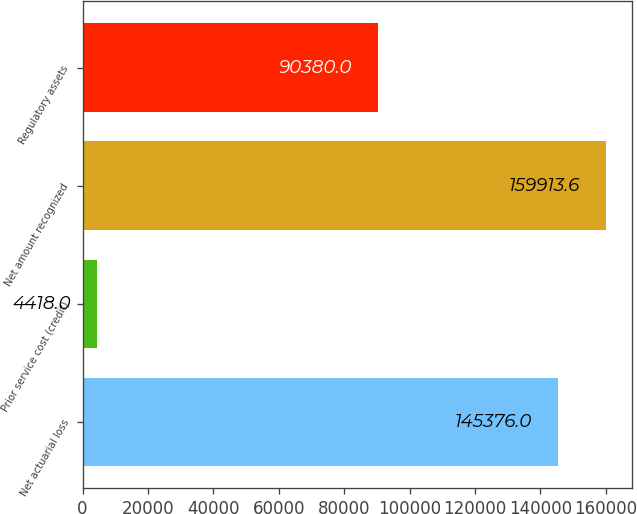<chart> <loc_0><loc_0><loc_500><loc_500><bar_chart><fcel>Net actuarial loss<fcel>Prior service cost (credit)<fcel>Net amount recognized<fcel>Regulatory assets<nl><fcel>145376<fcel>4418<fcel>159914<fcel>90380<nl></chart> 